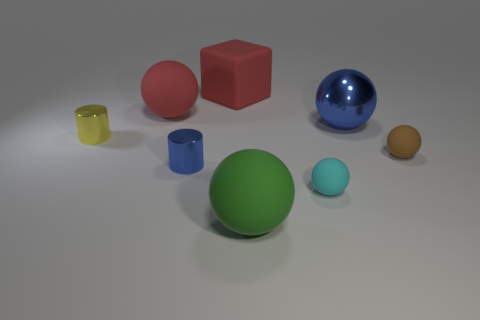Add 2 big shiny things. How many objects exist? 10 Subtract all large red balls. How many balls are left? 4 Subtract all cylinders. How many objects are left? 6 Subtract all green balls. How many balls are left? 4 Subtract 0 gray spheres. How many objects are left? 8 Subtract all red spheres. Subtract all green cylinders. How many spheres are left? 4 Subtract all tiny cyan matte blocks. Subtract all red rubber cubes. How many objects are left? 7 Add 3 large matte cubes. How many large matte cubes are left? 4 Add 6 big red matte things. How many big red matte things exist? 8 